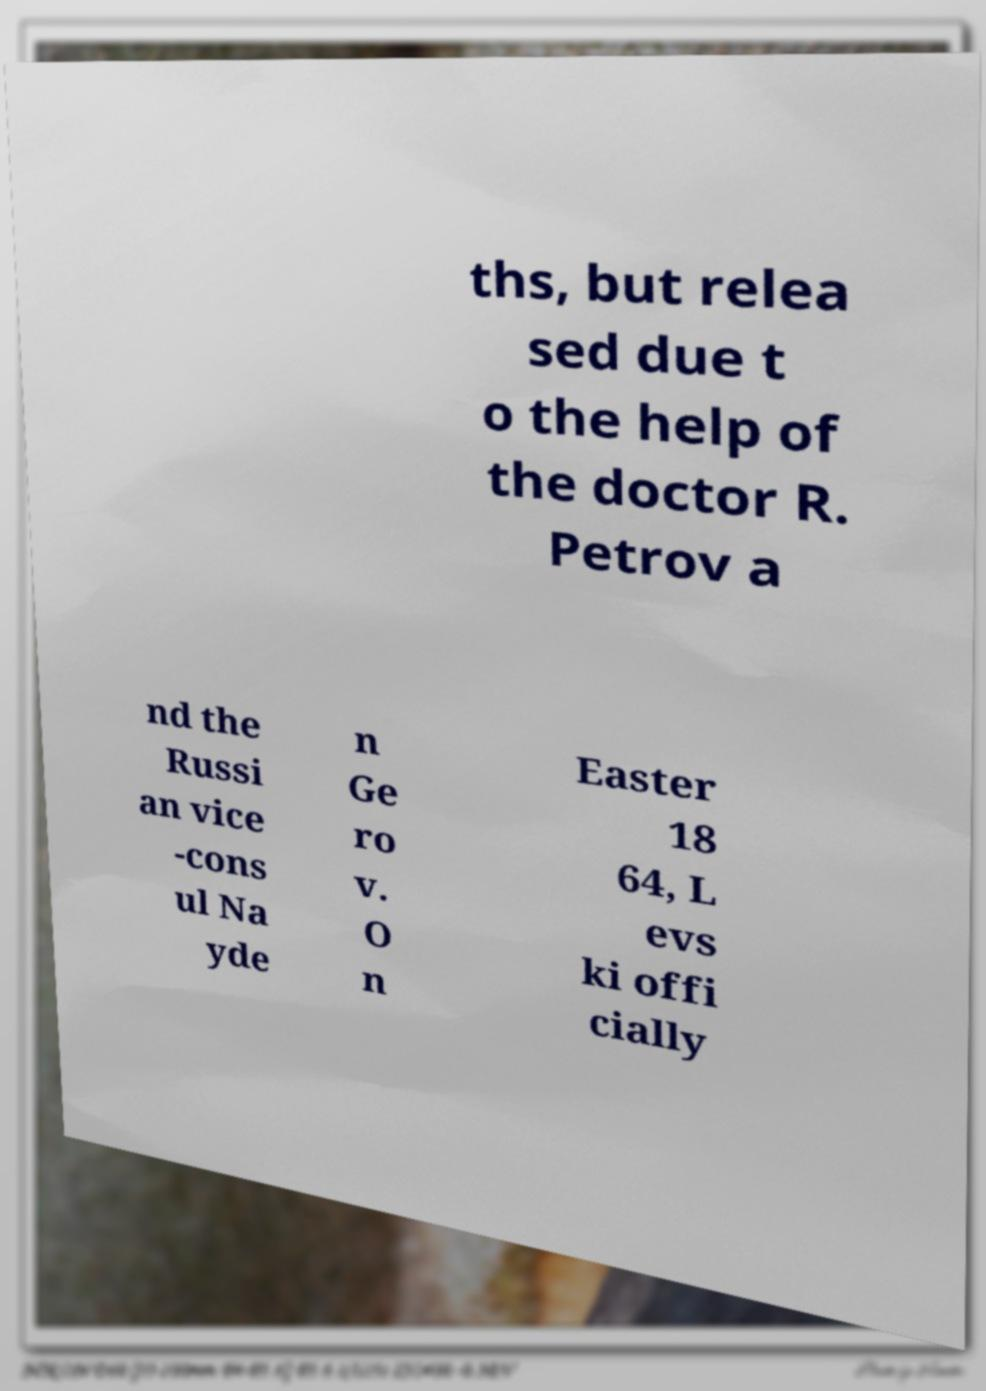Please read and relay the text visible in this image. What does it say? ths, but relea sed due t o the help of the doctor R. Petrov a nd the Russi an vice -cons ul Na yde n Ge ro v. O n Easter 18 64, L evs ki offi cially 